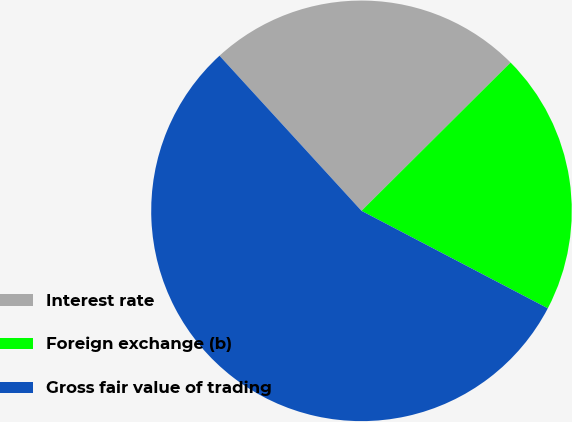Convert chart to OTSL. <chart><loc_0><loc_0><loc_500><loc_500><pie_chart><fcel>Interest rate<fcel>Foreign exchange (b)<fcel>Gross fair value of trading<nl><fcel>24.34%<fcel>20.13%<fcel>55.53%<nl></chart> 